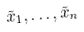<formula> <loc_0><loc_0><loc_500><loc_500>\tilde { x } _ { 1 } , \dots , \tilde { x } _ { n }</formula> 